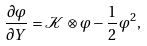<formula> <loc_0><loc_0><loc_500><loc_500>\frac { \partial \varphi } { \partial Y } = \mathcal { K } \otimes \varphi - \frac { 1 } { 2 } \, \varphi ^ { 2 } ,</formula> 